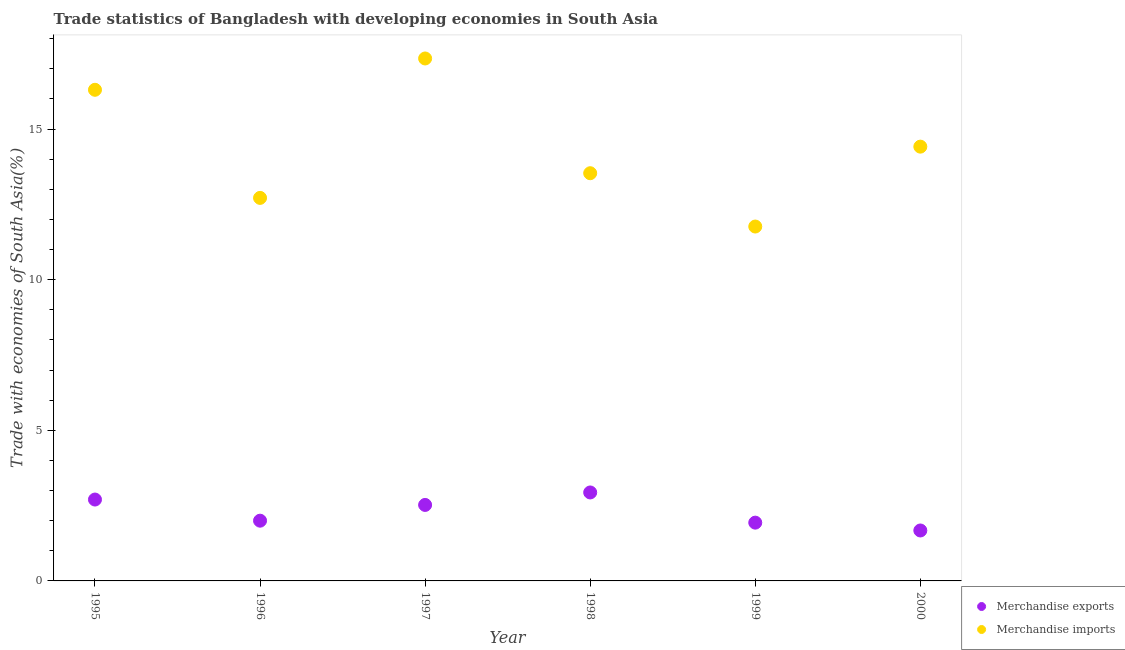How many different coloured dotlines are there?
Provide a short and direct response. 2. What is the merchandise imports in 1996?
Your response must be concise. 12.71. Across all years, what is the maximum merchandise imports?
Provide a succinct answer. 17.34. Across all years, what is the minimum merchandise imports?
Offer a very short reply. 11.76. In which year was the merchandise imports minimum?
Your answer should be very brief. 1999. What is the total merchandise imports in the graph?
Ensure brevity in your answer.  86.08. What is the difference between the merchandise imports in 1997 and that in 2000?
Your response must be concise. 2.93. What is the difference between the merchandise exports in 1997 and the merchandise imports in 1999?
Make the answer very short. -9.24. What is the average merchandise exports per year?
Your answer should be very brief. 2.29. In the year 2000, what is the difference between the merchandise imports and merchandise exports?
Give a very brief answer. 12.74. What is the ratio of the merchandise exports in 1996 to that in 2000?
Your response must be concise. 1.19. Is the merchandise imports in 1997 less than that in 2000?
Provide a succinct answer. No. Is the difference between the merchandise exports in 1995 and 2000 greater than the difference between the merchandise imports in 1995 and 2000?
Offer a very short reply. No. What is the difference between the highest and the second highest merchandise exports?
Offer a very short reply. 0.24. What is the difference between the highest and the lowest merchandise imports?
Give a very brief answer. 5.58. In how many years, is the merchandise exports greater than the average merchandise exports taken over all years?
Offer a terse response. 3. Does the merchandise imports monotonically increase over the years?
Your answer should be very brief. No. How many dotlines are there?
Your answer should be compact. 2. How many years are there in the graph?
Your response must be concise. 6. What is the difference between two consecutive major ticks on the Y-axis?
Your answer should be very brief. 5. Does the graph contain grids?
Keep it short and to the point. No. How are the legend labels stacked?
Give a very brief answer. Vertical. What is the title of the graph?
Ensure brevity in your answer.  Trade statistics of Bangladesh with developing economies in South Asia. Does "Urban Population" appear as one of the legend labels in the graph?
Provide a succinct answer. No. What is the label or title of the Y-axis?
Your answer should be very brief. Trade with economies of South Asia(%). What is the Trade with economies of South Asia(%) of Merchandise exports in 1995?
Ensure brevity in your answer.  2.7. What is the Trade with economies of South Asia(%) in Merchandise imports in 1995?
Your answer should be very brief. 16.3. What is the Trade with economies of South Asia(%) in Merchandise exports in 1996?
Offer a very short reply. 2. What is the Trade with economies of South Asia(%) in Merchandise imports in 1996?
Ensure brevity in your answer.  12.71. What is the Trade with economies of South Asia(%) of Merchandise exports in 1997?
Give a very brief answer. 2.52. What is the Trade with economies of South Asia(%) of Merchandise imports in 1997?
Your response must be concise. 17.34. What is the Trade with economies of South Asia(%) of Merchandise exports in 1998?
Your response must be concise. 2.94. What is the Trade with economies of South Asia(%) of Merchandise imports in 1998?
Your response must be concise. 13.53. What is the Trade with economies of South Asia(%) of Merchandise exports in 1999?
Provide a short and direct response. 1.93. What is the Trade with economies of South Asia(%) in Merchandise imports in 1999?
Your answer should be very brief. 11.76. What is the Trade with economies of South Asia(%) in Merchandise exports in 2000?
Ensure brevity in your answer.  1.67. What is the Trade with economies of South Asia(%) in Merchandise imports in 2000?
Ensure brevity in your answer.  14.42. Across all years, what is the maximum Trade with economies of South Asia(%) of Merchandise exports?
Offer a very short reply. 2.94. Across all years, what is the maximum Trade with economies of South Asia(%) in Merchandise imports?
Keep it short and to the point. 17.34. Across all years, what is the minimum Trade with economies of South Asia(%) of Merchandise exports?
Your answer should be very brief. 1.67. Across all years, what is the minimum Trade with economies of South Asia(%) of Merchandise imports?
Ensure brevity in your answer.  11.76. What is the total Trade with economies of South Asia(%) of Merchandise exports in the graph?
Your response must be concise. 13.77. What is the total Trade with economies of South Asia(%) of Merchandise imports in the graph?
Your response must be concise. 86.08. What is the difference between the Trade with economies of South Asia(%) of Merchandise exports in 1995 and that in 1996?
Your answer should be very brief. 0.7. What is the difference between the Trade with economies of South Asia(%) of Merchandise imports in 1995 and that in 1996?
Offer a very short reply. 3.59. What is the difference between the Trade with economies of South Asia(%) in Merchandise exports in 1995 and that in 1997?
Your response must be concise. 0.18. What is the difference between the Trade with economies of South Asia(%) in Merchandise imports in 1995 and that in 1997?
Provide a succinct answer. -1.04. What is the difference between the Trade with economies of South Asia(%) in Merchandise exports in 1995 and that in 1998?
Give a very brief answer. -0.24. What is the difference between the Trade with economies of South Asia(%) in Merchandise imports in 1995 and that in 1998?
Provide a succinct answer. 2.77. What is the difference between the Trade with economies of South Asia(%) in Merchandise exports in 1995 and that in 1999?
Keep it short and to the point. 0.77. What is the difference between the Trade with economies of South Asia(%) of Merchandise imports in 1995 and that in 1999?
Keep it short and to the point. 4.54. What is the difference between the Trade with economies of South Asia(%) in Merchandise exports in 1995 and that in 2000?
Offer a terse response. 1.03. What is the difference between the Trade with economies of South Asia(%) in Merchandise imports in 1995 and that in 2000?
Offer a very short reply. 1.89. What is the difference between the Trade with economies of South Asia(%) in Merchandise exports in 1996 and that in 1997?
Ensure brevity in your answer.  -0.52. What is the difference between the Trade with economies of South Asia(%) of Merchandise imports in 1996 and that in 1997?
Your answer should be compact. -4.63. What is the difference between the Trade with economies of South Asia(%) of Merchandise exports in 1996 and that in 1998?
Give a very brief answer. -0.94. What is the difference between the Trade with economies of South Asia(%) of Merchandise imports in 1996 and that in 1998?
Your answer should be very brief. -0.82. What is the difference between the Trade with economies of South Asia(%) in Merchandise exports in 1996 and that in 1999?
Give a very brief answer. 0.07. What is the difference between the Trade with economies of South Asia(%) in Merchandise imports in 1996 and that in 1999?
Keep it short and to the point. 0.95. What is the difference between the Trade with economies of South Asia(%) of Merchandise exports in 1996 and that in 2000?
Make the answer very short. 0.33. What is the difference between the Trade with economies of South Asia(%) of Merchandise imports in 1996 and that in 2000?
Your answer should be compact. -1.7. What is the difference between the Trade with economies of South Asia(%) in Merchandise exports in 1997 and that in 1998?
Offer a terse response. -0.41. What is the difference between the Trade with economies of South Asia(%) in Merchandise imports in 1997 and that in 1998?
Make the answer very short. 3.81. What is the difference between the Trade with economies of South Asia(%) in Merchandise exports in 1997 and that in 1999?
Provide a short and direct response. 0.59. What is the difference between the Trade with economies of South Asia(%) in Merchandise imports in 1997 and that in 1999?
Your response must be concise. 5.58. What is the difference between the Trade with economies of South Asia(%) of Merchandise exports in 1997 and that in 2000?
Provide a succinct answer. 0.85. What is the difference between the Trade with economies of South Asia(%) of Merchandise imports in 1997 and that in 2000?
Provide a short and direct response. 2.93. What is the difference between the Trade with economies of South Asia(%) of Merchandise imports in 1998 and that in 1999?
Make the answer very short. 1.77. What is the difference between the Trade with economies of South Asia(%) in Merchandise exports in 1998 and that in 2000?
Offer a terse response. 1.26. What is the difference between the Trade with economies of South Asia(%) of Merchandise imports in 1998 and that in 2000?
Offer a terse response. -0.88. What is the difference between the Trade with economies of South Asia(%) in Merchandise exports in 1999 and that in 2000?
Your response must be concise. 0.26. What is the difference between the Trade with economies of South Asia(%) in Merchandise imports in 1999 and that in 2000?
Keep it short and to the point. -2.65. What is the difference between the Trade with economies of South Asia(%) of Merchandise exports in 1995 and the Trade with economies of South Asia(%) of Merchandise imports in 1996?
Provide a short and direct response. -10.01. What is the difference between the Trade with economies of South Asia(%) in Merchandise exports in 1995 and the Trade with economies of South Asia(%) in Merchandise imports in 1997?
Your response must be concise. -14.64. What is the difference between the Trade with economies of South Asia(%) of Merchandise exports in 1995 and the Trade with economies of South Asia(%) of Merchandise imports in 1998?
Provide a succinct answer. -10.83. What is the difference between the Trade with economies of South Asia(%) of Merchandise exports in 1995 and the Trade with economies of South Asia(%) of Merchandise imports in 1999?
Your response must be concise. -9.06. What is the difference between the Trade with economies of South Asia(%) in Merchandise exports in 1995 and the Trade with economies of South Asia(%) in Merchandise imports in 2000?
Give a very brief answer. -11.71. What is the difference between the Trade with economies of South Asia(%) of Merchandise exports in 1996 and the Trade with economies of South Asia(%) of Merchandise imports in 1997?
Your response must be concise. -15.34. What is the difference between the Trade with economies of South Asia(%) of Merchandise exports in 1996 and the Trade with economies of South Asia(%) of Merchandise imports in 1998?
Provide a succinct answer. -11.53. What is the difference between the Trade with economies of South Asia(%) of Merchandise exports in 1996 and the Trade with economies of South Asia(%) of Merchandise imports in 1999?
Ensure brevity in your answer.  -9.76. What is the difference between the Trade with economies of South Asia(%) of Merchandise exports in 1996 and the Trade with economies of South Asia(%) of Merchandise imports in 2000?
Ensure brevity in your answer.  -12.42. What is the difference between the Trade with economies of South Asia(%) of Merchandise exports in 1997 and the Trade with economies of South Asia(%) of Merchandise imports in 1998?
Provide a short and direct response. -11.01. What is the difference between the Trade with economies of South Asia(%) in Merchandise exports in 1997 and the Trade with economies of South Asia(%) in Merchandise imports in 1999?
Offer a terse response. -9.24. What is the difference between the Trade with economies of South Asia(%) in Merchandise exports in 1997 and the Trade with economies of South Asia(%) in Merchandise imports in 2000?
Provide a succinct answer. -11.89. What is the difference between the Trade with economies of South Asia(%) of Merchandise exports in 1998 and the Trade with economies of South Asia(%) of Merchandise imports in 1999?
Your response must be concise. -8.83. What is the difference between the Trade with economies of South Asia(%) in Merchandise exports in 1998 and the Trade with economies of South Asia(%) in Merchandise imports in 2000?
Ensure brevity in your answer.  -11.48. What is the difference between the Trade with economies of South Asia(%) of Merchandise exports in 1999 and the Trade with economies of South Asia(%) of Merchandise imports in 2000?
Your response must be concise. -12.48. What is the average Trade with economies of South Asia(%) of Merchandise exports per year?
Provide a short and direct response. 2.29. What is the average Trade with economies of South Asia(%) of Merchandise imports per year?
Provide a succinct answer. 14.35. In the year 1995, what is the difference between the Trade with economies of South Asia(%) in Merchandise exports and Trade with economies of South Asia(%) in Merchandise imports?
Your answer should be very brief. -13.6. In the year 1996, what is the difference between the Trade with economies of South Asia(%) in Merchandise exports and Trade with economies of South Asia(%) in Merchandise imports?
Your answer should be compact. -10.72. In the year 1997, what is the difference between the Trade with economies of South Asia(%) of Merchandise exports and Trade with economies of South Asia(%) of Merchandise imports?
Give a very brief answer. -14.82. In the year 1998, what is the difference between the Trade with economies of South Asia(%) in Merchandise exports and Trade with economies of South Asia(%) in Merchandise imports?
Offer a very short reply. -10.6. In the year 1999, what is the difference between the Trade with economies of South Asia(%) in Merchandise exports and Trade with economies of South Asia(%) in Merchandise imports?
Your answer should be very brief. -9.83. In the year 2000, what is the difference between the Trade with economies of South Asia(%) of Merchandise exports and Trade with economies of South Asia(%) of Merchandise imports?
Make the answer very short. -12.74. What is the ratio of the Trade with economies of South Asia(%) in Merchandise exports in 1995 to that in 1996?
Give a very brief answer. 1.35. What is the ratio of the Trade with economies of South Asia(%) of Merchandise imports in 1995 to that in 1996?
Give a very brief answer. 1.28. What is the ratio of the Trade with economies of South Asia(%) in Merchandise exports in 1995 to that in 1997?
Your answer should be compact. 1.07. What is the ratio of the Trade with economies of South Asia(%) of Merchandise imports in 1995 to that in 1997?
Your answer should be very brief. 0.94. What is the ratio of the Trade with economies of South Asia(%) in Merchandise exports in 1995 to that in 1998?
Your answer should be compact. 0.92. What is the ratio of the Trade with economies of South Asia(%) in Merchandise imports in 1995 to that in 1998?
Provide a succinct answer. 1.2. What is the ratio of the Trade with economies of South Asia(%) in Merchandise exports in 1995 to that in 1999?
Provide a succinct answer. 1.4. What is the ratio of the Trade with economies of South Asia(%) in Merchandise imports in 1995 to that in 1999?
Give a very brief answer. 1.39. What is the ratio of the Trade with economies of South Asia(%) of Merchandise exports in 1995 to that in 2000?
Offer a terse response. 1.61. What is the ratio of the Trade with economies of South Asia(%) of Merchandise imports in 1995 to that in 2000?
Ensure brevity in your answer.  1.13. What is the ratio of the Trade with economies of South Asia(%) in Merchandise exports in 1996 to that in 1997?
Give a very brief answer. 0.79. What is the ratio of the Trade with economies of South Asia(%) in Merchandise imports in 1996 to that in 1997?
Offer a very short reply. 0.73. What is the ratio of the Trade with economies of South Asia(%) in Merchandise exports in 1996 to that in 1998?
Provide a short and direct response. 0.68. What is the ratio of the Trade with economies of South Asia(%) of Merchandise imports in 1996 to that in 1998?
Make the answer very short. 0.94. What is the ratio of the Trade with economies of South Asia(%) in Merchandise exports in 1996 to that in 1999?
Your answer should be compact. 1.03. What is the ratio of the Trade with economies of South Asia(%) of Merchandise imports in 1996 to that in 1999?
Ensure brevity in your answer.  1.08. What is the ratio of the Trade with economies of South Asia(%) of Merchandise exports in 1996 to that in 2000?
Provide a short and direct response. 1.19. What is the ratio of the Trade with economies of South Asia(%) of Merchandise imports in 1996 to that in 2000?
Ensure brevity in your answer.  0.88. What is the ratio of the Trade with economies of South Asia(%) in Merchandise exports in 1997 to that in 1998?
Your response must be concise. 0.86. What is the ratio of the Trade with economies of South Asia(%) in Merchandise imports in 1997 to that in 1998?
Make the answer very short. 1.28. What is the ratio of the Trade with economies of South Asia(%) of Merchandise exports in 1997 to that in 1999?
Provide a succinct answer. 1.3. What is the ratio of the Trade with economies of South Asia(%) of Merchandise imports in 1997 to that in 1999?
Your response must be concise. 1.47. What is the ratio of the Trade with economies of South Asia(%) in Merchandise exports in 1997 to that in 2000?
Offer a terse response. 1.51. What is the ratio of the Trade with economies of South Asia(%) of Merchandise imports in 1997 to that in 2000?
Keep it short and to the point. 1.2. What is the ratio of the Trade with economies of South Asia(%) in Merchandise exports in 1998 to that in 1999?
Provide a succinct answer. 1.52. What is the ratio of the Trade with economies of South Asia(%) of Merchandise imports in 1998 to that in 1999?
Provide a succinct answer. 1.15. What is the ratio of the Trade with economies of South Asia(%) of Merchandise exports in 1998 to that in 2000?
Provide a succinct answer. 1.75. What is the ratio of the Trade with economies of South Asia(%) of Merchandise imports in 1998 to that in 2000?
Your answer should be very brief. 0.94. What is the ratio of the Trade with economies of South Asia(%) of Merchandise exports in 1999 to that in 2000?
Provide a succinct answer. 1.16. What is the ratio of the Trade with economies of South Asia(%) of Merchandise imports in 1999 to that in 2000?
Offer a terse response. 0.82. What is the difference between the highest and the second highest Trade with economies of South Asia(%) of Merchandise exports?
Ensure brevity in your answer.  0.24. What is the difference between the highest and the second highest Trade with economies of South Asia(%) of Merchandise imports?
Provide a succinct answer. 1.04. What is the difference between the highest and the lowest Trade with economies of South Asia(%) of Merchandise exports?
Your answer should be very brief. 1.26. What is the difference between the highest and the lowest Trade with economies of South Asia(%) in Merchandise imports?
Offer a terse response. 5.58. 